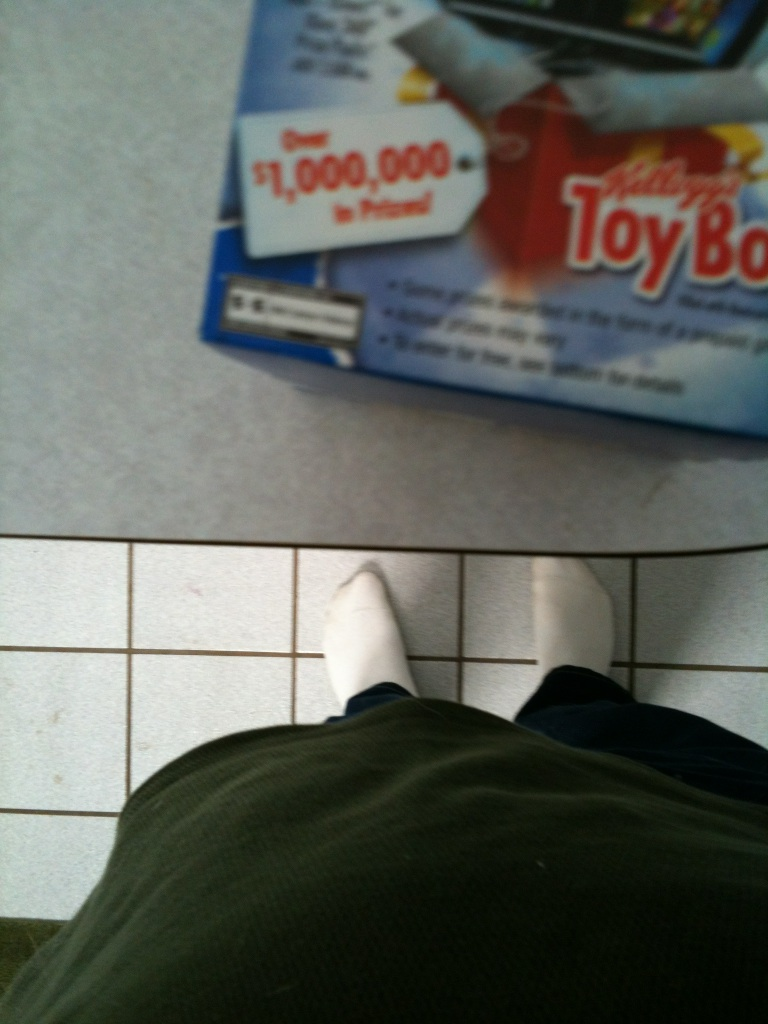What kind of product might this box contain related to the theme 'Toy Box'? Given the theme 'Toy Box', the box might contain toys or a special edition product aimed at children, possibly including a collectible or a toy as part of a marketing campaign. Could this product be linked to a specific event or popular culture theme? Yes, products named 'Toy Box' could be linked to a specific event like a movie release, or themed around popular children's characters to attract a younger audience. 